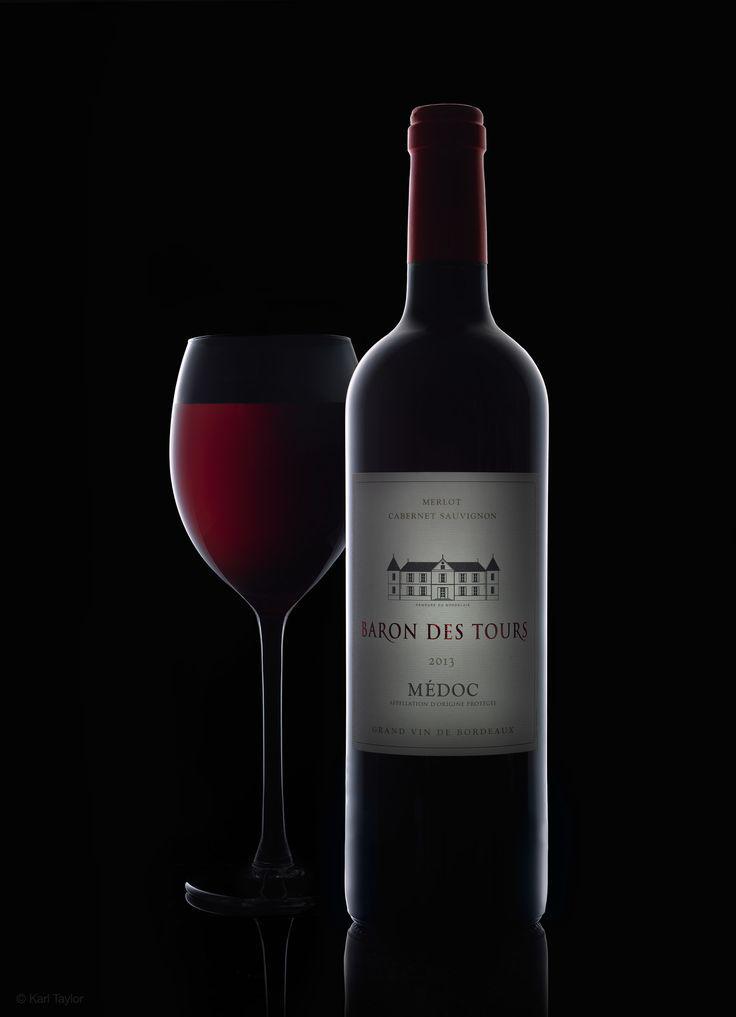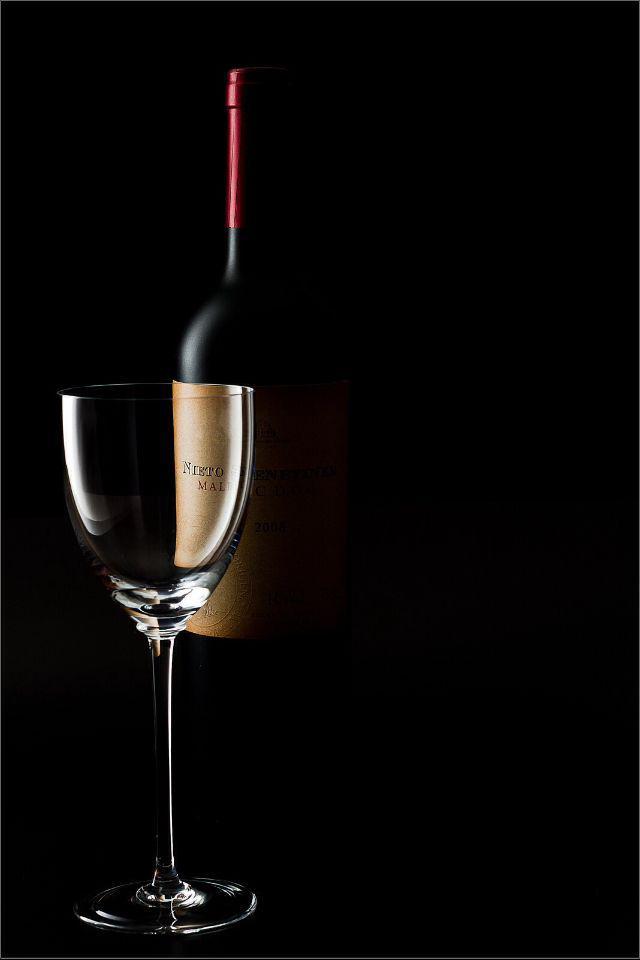The first image is the image on the left, the second image is the image on the right. Evaluate the accuracy of this statement regarding the images: "There are two wineglasses in one of the images.". Is it true? Answer yes or no. No. 